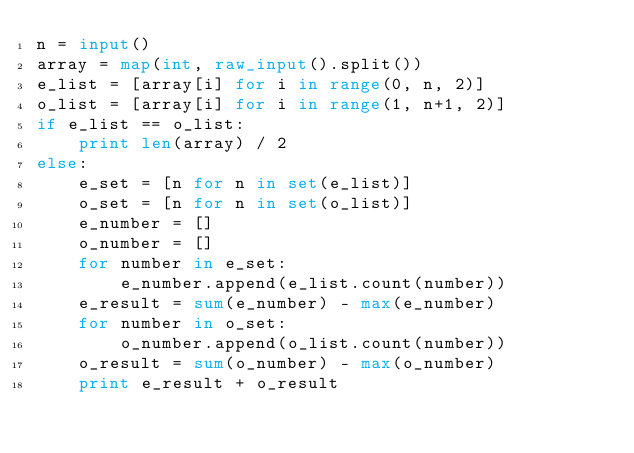Convert code to text. <code><loc_0><loc_0><loc_500><loc_500><_Python_>n = input()
array = map(int, raw_input().split())
e_list = [array[i] for i in range(0, n, 2)]
o_list = [array[i] for i in range(1, n+1, 2)]
if e_list == o_list:
    print len(array) / 2
else:
    e_set = [n for n in set(e_list)]
    o_set = [n for n in set(o_list)]
    e_number = []
    o_number = []
    for number in e_set:
        e_number.append(e_list.count(number))
    e_result = sum(e_number) - max(e_number)
    for number in o_set:
        o_number.append(o_list.count(number))
    o_result = sum(o_number) - max(o_number)
    print e_result + o_result
</code> 